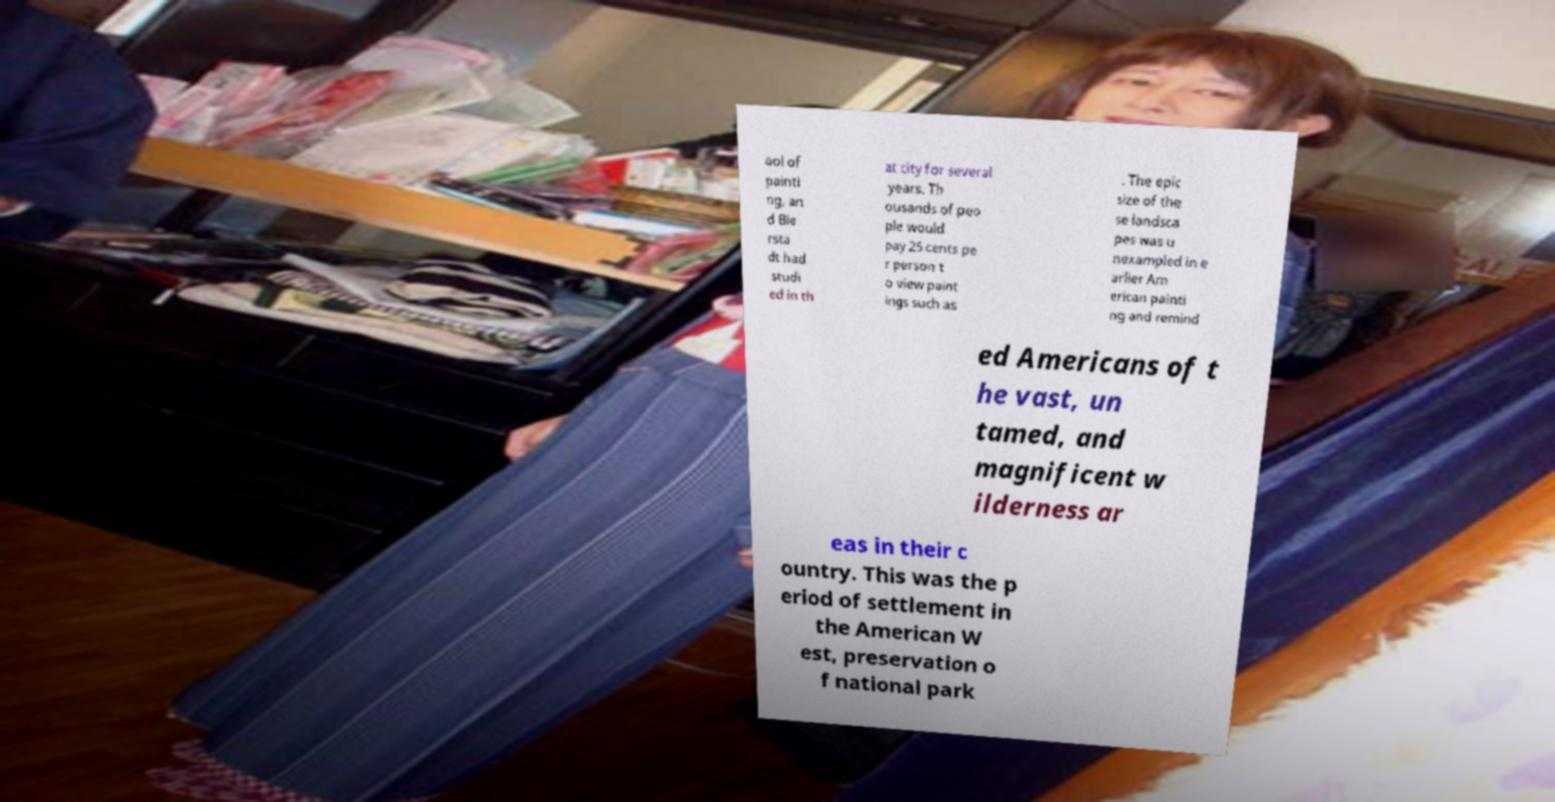What messages or text are displayed in this image? I need them in a readable, typed format. ool of painti ng, an d Bie rsta dt had studi ed in th at city for several years. Th ousands of peo ple would pay 25 cents pe r person t o view paint ings such as . The epic size of the se landsca pes was u nexampled in e arlier Am erican painti ng and remind ed Americans of t he vast, un tamed, and magnificent w ilderness ar eas in their c ountry. This was the p eriod of settlement in the American W est, preservation o f national park 